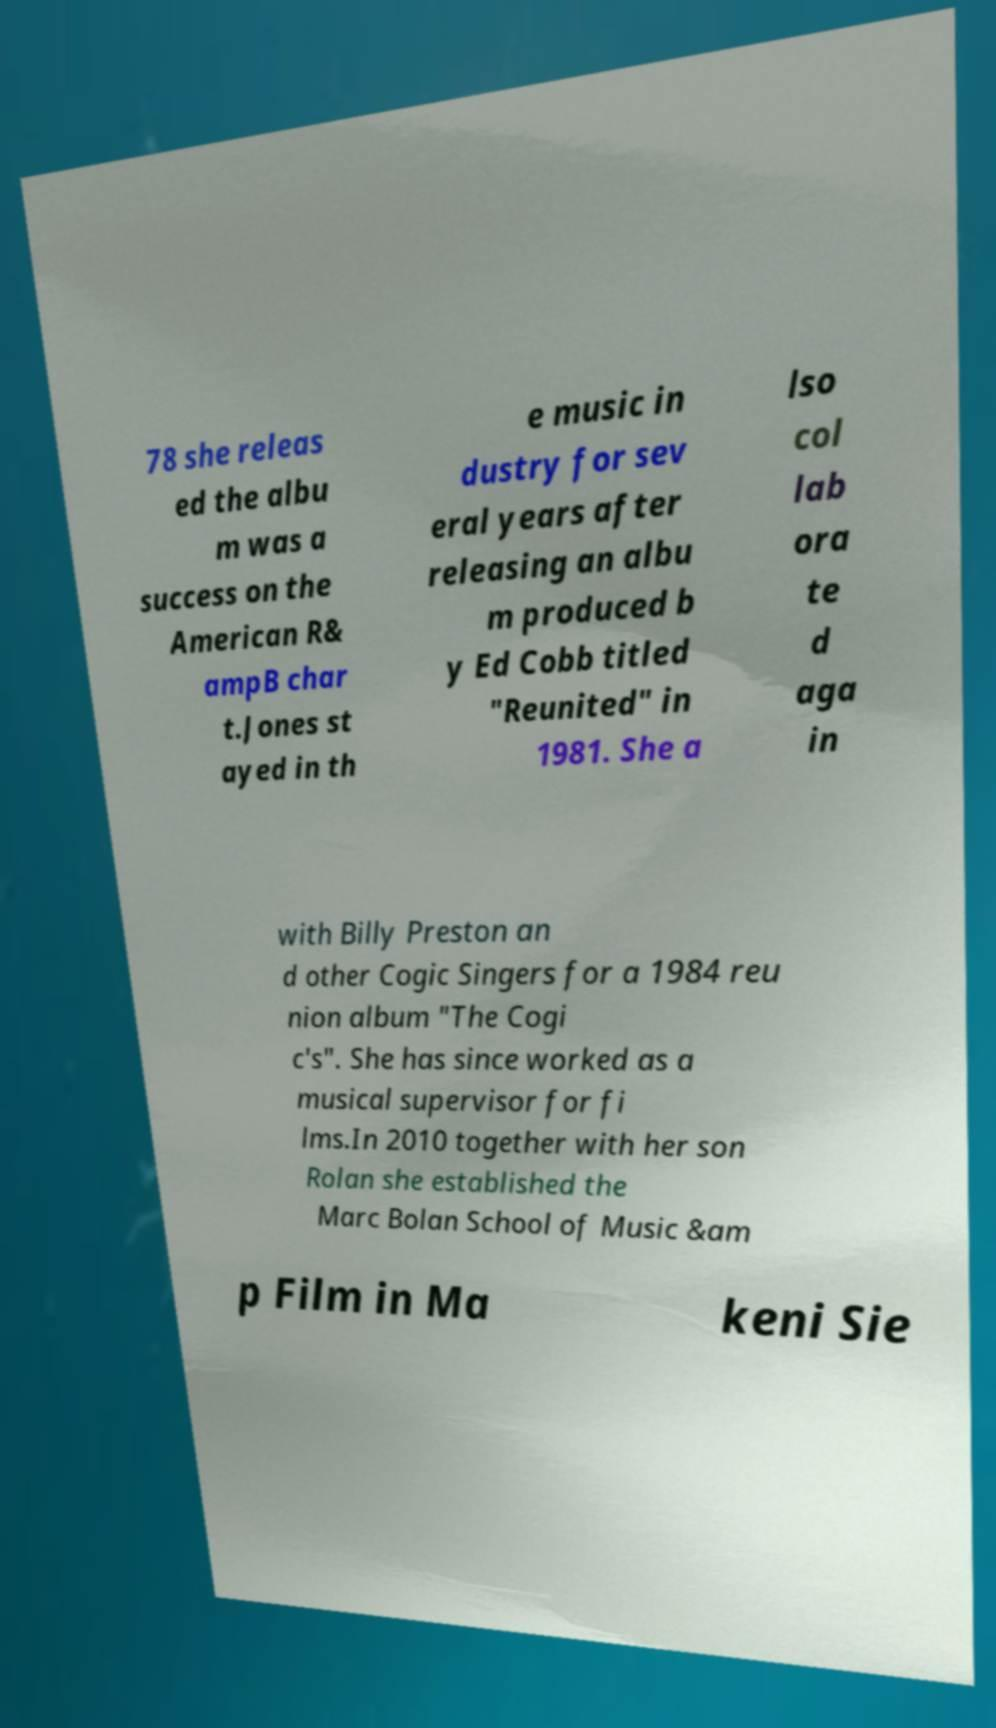Could you assist in decoding the text presented in this image and type it out clearly? 78 she releas ed the albu m was a success on the American R& ampB char t.Jones st ayed in th e music in dustry for sev eral years after releasing an albu m produced b y Ed Cobb titled "Reunited" in 1981. She a lso col lab ora te d aga in with Billy Preston an d other Cogic Singers for a 1984 reu nion album "The Cogi c's". She has since worked as a musical supervisor for fi lms.In 2010 together with her son Rolan she established the Marc Bolan School of Music &am p Film in Ma keni Sie 